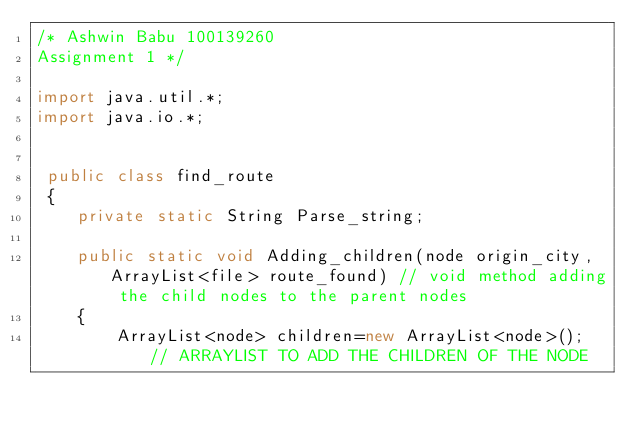<code> <loc_0><loc_0><loc_500><loc_500><_Java_>/* Ashwin Babu 100139260
Assignment 1 */

import java.util.*;
import java.io.*;


 public class find_route
 {
	private static String Parse_string; 

 	public static void Adding_children(node origin_city,ArrayList<file> route_found) // void method adding the child nodes to the parent nodes
 	{	
 		ArrayList<node> children=new ArrayList<node>(); // ARRAYLIST TO ADD THE CHILDREN OF THE NODE
</code> 